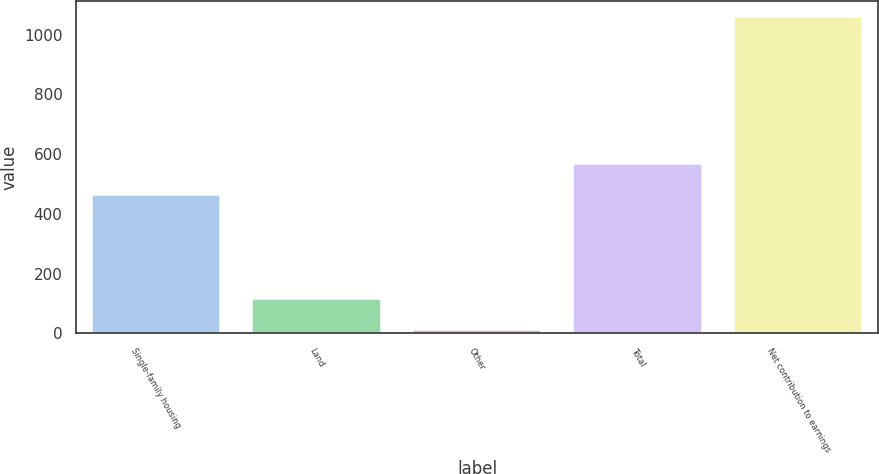Convert chart to OTSL. <chart><loc_0><loc_0><loc_500><loc_500><bar_chart><fcel>Single-family housing<fcel>Land<fcel>Other<fcel>Total<fcel>Net contribution to earnings<nl><fcel>462<fcel>115.7<fcel>11<fcel>566.7<fcel>1058<nl></chart> 